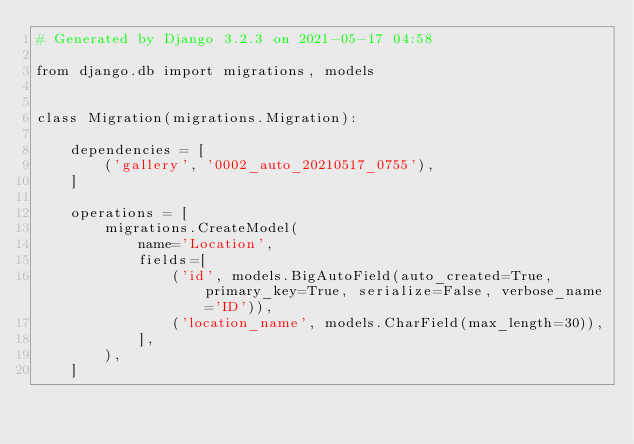Convert code to text. <code><loc_0><loc_0><loc_500><loc_500><_Python_># Generated by Django 3.2.3 on 2021-05-17 04:58

from django.db import migrations, models


class Migration(migrations.Migration):

    dependencies = [
        ('gallery', '0002_auto_20210517_0755'),
    ]

    operations = [
        migrations.CreateModel(
            name='Location',
            fields=[
                ('id', models.BigAutoField(auto_created=True, primary_key=True, serialize=False, verbose_name='ID')),
                ('location_name', models.CharField(max_length=30)),
            ],
        ),
    ]
</code> 